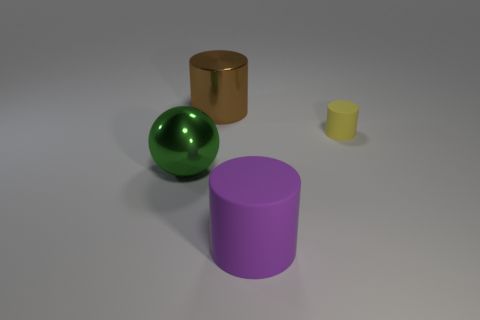Add 3 big green shiny spheres. How many objects exist? 7 Subtract all metallic cylinders. How many cylinders are left? 2 Add 2 green shiny cylinders. How many green shiny cylinders exist? 2 Subtract all brown cylinders. How many cylinders are left? 2 Subtract 0 cyan cubes. How many objects are left? 4 Subtract all cylinders. How many objects are left? 1 Subtract all yellow cylinders. Subtract all gray spheres. How many cylinders are left? 2 Subtract all green balls. How many gray cylinders are left? 0 Subtract all tiny green metal things. Subtract all brown shiny objects. How many objects are left? 3 Add 1 large brown cylinders. How many large brown cylinders are left? 2 